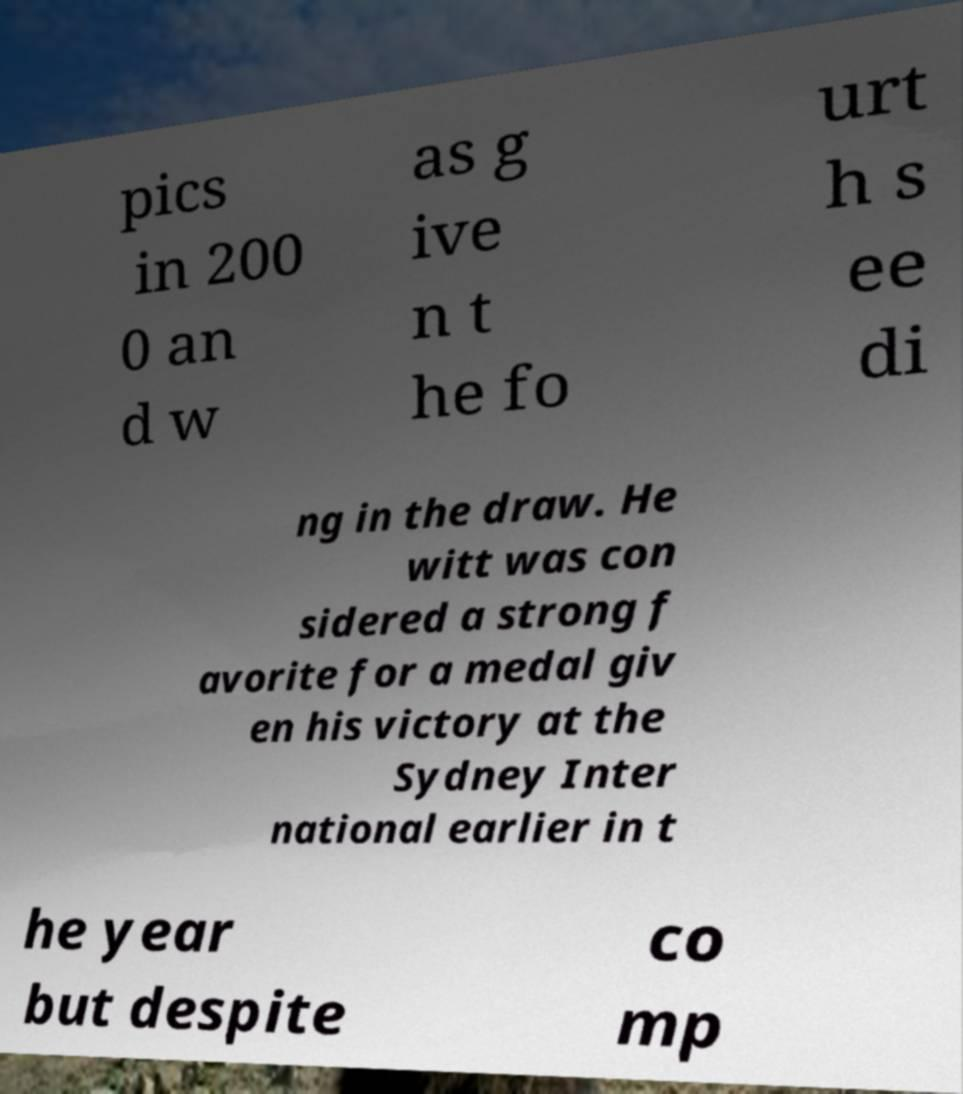I need the written content from this picture converted into text. Can you do that? pics in 200 0 an d w as g ive n t he fo urt h s ee di ng in the draw. He witt was con sidered a strong f avorite for a medal giv en his victory at the Sydney Inter national earlier in t he year but despite co mp 